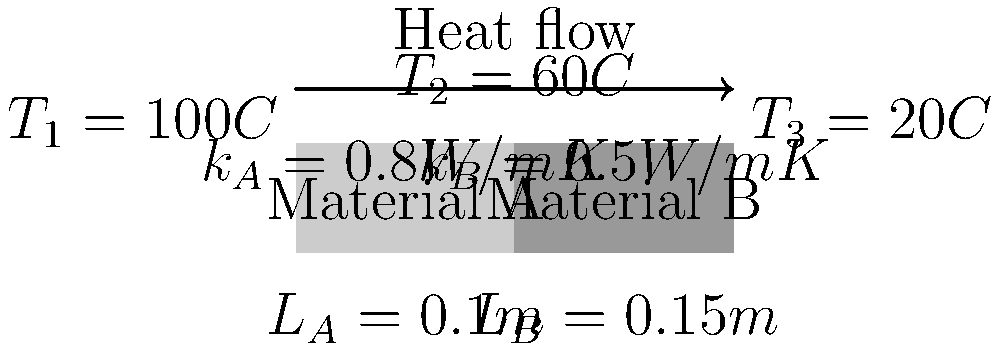In a composite wall consisting of two layers (Material A and Material B) with different thermal conductivities, the temperature at the left surface is $100°C$, at the interface between materials is $60°C$, and at the right surface is $20°C$. Given the thermal conductivities and thicknesses shown in the diagram, calculate the heat flux through the wall in $W/m^2$. To solve this problem, we'll use Fourier's law of heat conduction and the concept of thermal resistance in series. Let's proceed step-by-step:

1) Fourier's law of heat conduction: $q = -k \frac{dT}{dx}$

2) For a composite wall, we can use the thermal resistance analogy:
   $q = \frac{T_1 - T_3}{R_{total}}$, where $R_{total} = R_A + R_B$

3) Thermal resistance for each layer: $R = \frac{L}{k}$
   $R_A = \frac{L_A}{k_A} = \frac{0.1}{0.8} = 0.125 m^2K/W$
   $R_B = \frac{L_B}{k_B} = \frac{0.15}{0.5} = 0.3 m^2K/W$

4) Total thermal resistance:
   $R_{total} = R_A + R_B = 0.125 + 0.3 = 0.425 m^2K/W$

5) Now we can calculate the heat flux:
   $q = \frac{T_1 - T_3}{R_{total}} = \frac{100°C - 20°C}{0.425 m^2K/W} = \frac{80}{0.425} = 188.24 W/m^2$

Therefore, the heat flux through the composite wall is approximately 188.24 W/m².
Answer: 188.24 W/m² 